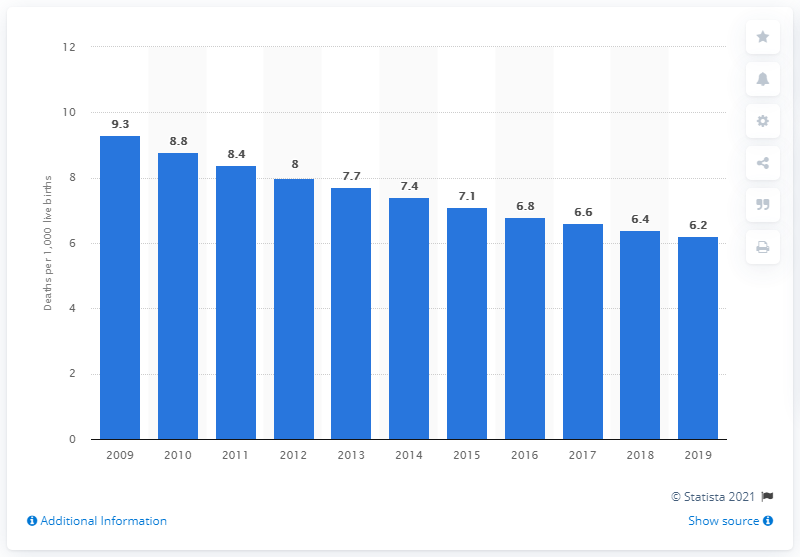Mention a couple of crucial points in this snapshot. In 2019, the infant mortality rate in Lebanon was 6.2 deaths per 1,000 live births. 